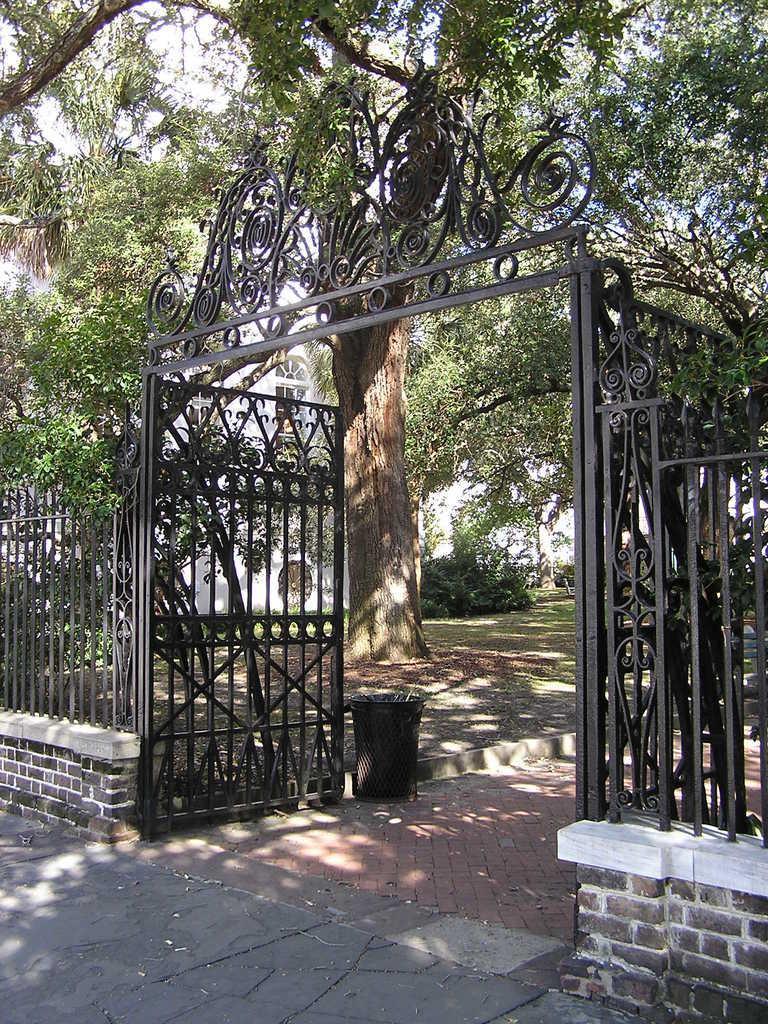Please provide a concise description of this image. In the picture we can see a black gate which is opened and besides the gate we can see black color railings and inside the gate we can see some plants, trees and from it we can see a building wall which is white in color with window to it. 